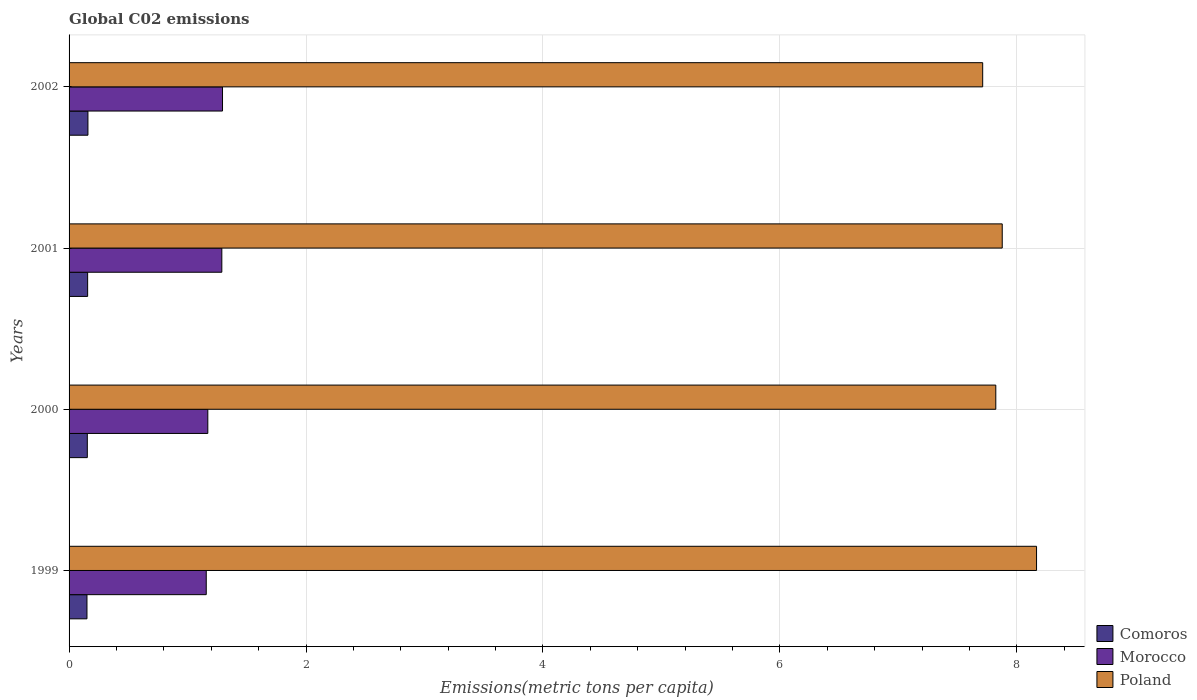Are the number of bars per tick equal to the number of legend labels?
Your response must be concise. Yes. Are the number of bars on each tick of the Y-axis equal?
Give a very brief answer. Yes. What is the label of the 4th group of bars from the top?
Your answer should be compact. 1999. In how many cases, is the number of bars for a given year not equal to the number of legend labels?
Provide a short and direct response. 0. What is the amount of CO2 emitted in in Comoros in 2001?
Offer a very short reply. 0.16. Across all years, what is the maximum amount of CO2 emitted in in Poland?
Offer a very short reply. 8.17. Across all years, what is the minimum amount of CO2 emitted in in Comoros?
Your response must be concise. 0.15. In which year was the amount of CO2 emitted in in Morocco maximum?
Give a very brief answer. 2002. What is the total amount of CO2 emitted in in Poland in the graph?
Offer a very short reply. 31.58. What is the difference between the amount of CO2 emitted in in Comoros in 1999 and that in 2000?
Your answer should be very brief. -0. What is the difference between the amount of CO2 emitted in in Comoros in 1999 and the amount of CO2 emitted in in Morocco in 2002?
Provide a short and direct response. -1.14. What is the average amount of CO2 emitted in in Poland per year?
Make the answer very short. 7.89. In the year 2002, what is the difference between the amount of CO2 emitted in in Morocco and amount of CO2 emitted in in Poland?
Your answer should be compact. -6.42. In how many years, is the amount of CO2 emitted in in Comoros greater than 6 metric tons per capita?
Provide a succinct answer. 0. What is the ratio of the amount of CO2 emitted in in Poland in 2000 to that in 2002?
Provide a short and direct response. 1.01. Is the difference between the amount of CO2 emitted in in Morocco in 2001 and 2002 greater than the difference between the amount of CO2 emitted in in Poland in 2001 and 2002?
Provide a succinct answer. No. What is the difference between the highest and the second highest amount of CO2 emitted in in Morocco?
Your response must be concise. 0.01. What is the difference between the highest and the lowest amount of CO2 emitted in in Comoros?
Offer a very short reply. 0.01. Is the sum of the amount of CO2 emitted in in Comoros in 1999 and 2002 greater than the maximum amount of CO2 emitted in in Poland across all years?
Offer a terse response. No. What does the 2nd bar from the top in 2001 represents?
Your answer should be compact. Morocco. Is it the case that in every year, the sum of the amount of CO2 emitted in in Morocco and amount of CO2 emitted in in Poland is greater than the amount of CO2 emitted in in Comoros?
Your answer should be compact. Yes. What is the difference between two consecutive major ticks on the X-axis?
Your response must be concise. 2. Does the graph contain any zero values?
Ensure brevity in your answer.  No. Where does the legend appear in the graph?
Provide a succinct answer. Bottom right. How are the legend labels stacked?
Give a very brief answer. Vertical. What is the title of the graph?
Ensure brevity in your answer.  Global C02 emissions. What is the label or title of the X-axis?
Make the answer very short. Emissions(metric tons per capita). What is the label or title of the Y-axis?
Your answer should be compact. Years. What is the Emissions(metric tons per capita) in Comoros in 1999?
Offer a terse response. 0.15. What is the Emissions(metric tons per capita) of Morocco in 1999?
Give a very brief answer. 1.16. What is the Emissions(metric tons per capita) of Poland in 1999?
Provide a succinct answer. 8.17. What is the Emissions(metric tons per capita) in Comoros in 2000?
Your response must be concise. 0.15. What is the Emissions(metric tons per capita) of Morocco in 2000?
Offer a very short reply. 1.17. What is the Emissions(metric tons per capita) in Poland in 2000?
Make the answer very short. 7.82. What is the Emissions(metric tons per capita) of Comoros in 2001?
Make the answer very short. 0.16. What is the Emissions(metric tons per capita) of Morocco in 2001?
Offer a very short reply. 1.29. What is the Emissions(metric tons per capita) in Poland in 2001?
Give a very brief answer. 7.88. What is the Emissions(metric tons per capita) in Comoros in 2002?
Keep it short and to the point. 0.16. What is the Emissions(metric tons per capita) in Morocco in 2002?
Offer a very short reply. 1.3. What is the Emissions(metric tons per capita) in Poland in 2002?
Give a very brief answer. 7.71. Across all years, what is the maximum Emissions(metric tons per capita) of Comoros?
Your response must be concise. 0.16. Across all years, what is the maximum Emissions(metric tons per capita) in Morocco?
Offer a terse response. 1.3. Across all years, what is the maximum Emissions(metric tons per capita) in Poland?
Make the answer very short. 8.17. Across all years, what is the minimum Emissions(metric tons per capita) in Comoros?
Ensure brevity in your answer.  0.15. Across all years, what is the minimum Emissions(metric tons per capita) of Morocco?
Offer a very short reply. 1.16. Across all years, what is the minimum Emissions(metric tons per capita) of Poland?
Offer a very short reply. 7.71. What is the total Emissions(metric tons per capita) in Comoros in the graph?
Your answer should be very brief. 0.62. What is the total Emissions(metric tons per capita) in Morocco in the graph?
Offer a very short reply. 4.91. What is the total Emissions(metric tons per capita) in Poland in the graph?
Keep it short and to the point. 31.58. What is the difference between the Emissions(metric tons per capita) of Comoros in 1999 and that in 2000?
Ensure brevity in your answer.  -0. What is the difference between the Emissions(metric tons per capita) in Morocco in 1999 and that in 2000?
Make the answer very short. -0.01. What is the difference between the Emissions(metric tons per capita) in Poland in 1999 and that in 2000?
Make the answer very short. 0.34. What is the difference between the Emissions(metric tons per capita) in Comoros in 1999 and that in 2001?
Your response must be concise. -0.01. What is the difference between the Emissions(metric tons per capita) of Morocco in 1999 and that in 2001?
Keep it short and to the point. -0.13. What is the difference between the Emissions(metric tons per capita) of Poland in 1999 and that in 2001?
Provide a short and direct response. 0.29. What is the difference between the Emissions(metric tons per capita) in Comoros in 1999 and that in 2002?
Give a very brief answer. -0.01. What is the difference between the Emissions(metric tons per capita) of Morocco in 1999 and that in 2002?
Ensure brevity in your answer.  -0.14. What is the difference between the Emissions(metric tons per capita) of Poland in 1999 and that in 2002?
Make the answer very short. 0.45. What is the difference between the Emissions(metric tons per capita) of Comoros in 2000 and that in 2001?
Keep it short and to the point. -0. What is the difference between the Emissions(metric tons per capita) in Morocco in 2000 and that in 2001?
Keep it short and to the point. -0.12. What is the difference between the Emissions(metric tons per capita) in Poland in 2000 and that in 2001?
Keep it short and to the point. -0.05. What is the difference between the Emissions(metric tons per capita) in Comoros in 2000 and that in 2002?
Make the answer very short. -0.01. What is the difference between the Emissions(metric tons per capita) of Morocco in 2000 and that in 2002?
Provide a succinct answer. -0.12. What is the difference between the Emissions(metric tons per capita) in Poland in 2000 and that in 2002?
Give a very brief answer. 0.11. What is the difference between the Emissions(metric tons per capita) in Comoros in 2001 and that in 2002?
Your answer should be compact. -0. What is the difference between the Emissions(metric tons per capita) of Morocco in 2001 and that in 2002?
Provide a succinct answer. -0.01. What is the difference between the Emissions(metric tons per capita) in Poland in 2001 and that in 2002?
Your answer should be compact. 0.17. What is the difference between the Emissions(metric tons per capita) of Comoros in 1999 and the Emissions(metric tons per capita) of Morocco in 2000?
Make the answer very short. -1.02. What is the difference between the Emissions(metric tons per capita) in Comoros in 1999 and the Emissions(metric tons per capita) in Poland in 2000?
Your response must be concise. -7.67. What is the difference between the Emissions(metric tons per capita) of Morocco in 1999 and the Emissions(metric tons per capita) of Poland in 2000?
Provide a succinct answer. -6.66. What is the difference between the Emissions(metric tons per capita) of Comoros in 1999 and the Emissions(metric tons per capita) of Morocco in 2001?
Offer a terse response. -1.14. What is the difference between the Emissions(metric tons per capita) of Comoros in 1999 and the Emissions(metric tons per capita) of Poland in 2001?
Provide a succinct answer. -7.73. What is the difference between the Emissions(metric tons per capita) in Morocco in 1999 and the Emissions(metric tons per capita) in Poland in 2001?
Keep it short and to the point. -6.72. What is the difference between the Emissions(metric tons per capita) in Comoros in 1999 and the Emissions(metric tons per capita) in Morocco in 2002?
Make the answer very short. -1.14. What is the difference between the Emissions(metric tons per capita) of Comoros in 1999 and the Emissions(metric tons per capita) of Poland in 2002?
Make the answer very short. -7.56. What is the difference between the Emissions(metric tons per capita) of Morocco in 1999 and the Emissions(metric tons per capita) of Poland in 2002?
Your answer should be very brief. -6.55. What is the difference between the Emissions(metric tons per capita) of Comoros in 2000 and the Emissions(metric tons per capita) of Morocco in 2001?
Your response must be concise. -1.14. What is the difference between the Emissions(metric tons per capita) in Comoros in 2000 and the Emissions(metric tons per capita) in Poland in 2001?
Your answer should be compact. -7.72. What is the difference between the Emissions(metric tons per capita) in Morocco in 2000 and the Emissions(metric tons per capita) in Poland in 2001?
Ensure brevity in your answer.  -6.71. What is the difference between the Emissions(metric tons per capita) in Comoros in 2000 and the Emissions(metric tons per capita) in Morocco in 2002?
Ensure brevity in your answer.  -1.14. What is the difference between the Emissions(metric tons per capita) in Comoros in 2000 and the Emissions(metric tons per capita) in Poland in 2002?
Make the answer very short. -7.56. What is the difference between the Emissions(metric tons per capita) of Morocco in 2000 and the Emissions(metric tons per capita) of Poland in 2002?
Your answer should be very brief. -6.54. What is the difference between the Emissions(metric tons per capita) in Comoros in 2001 and the Emissions(metric tons per capita) in Morocco in 2002?
Your answer should be compact. -1.14. What is the difference between the Emissions(metric tons per capita) of Comoros in 2001 and the Emissions(metric tons per capita) of Poland in 2002?
Your response must be concise. -7.55. What is the difference between the Emissions(metric tons per capita) of Morocco in 2001 and the Emissions(metric tons per capita) of Poland in 2002?
Your response must be concise. -6.42. What is the average Emissions(metric tons per capita) of Comoros per year?
Give a very brief answer. 0.16. What is the average Emissions(metric tons per capita) in Morocco per year?
Provide a short and direct response. 1.23. What is the average Emissions(metric tons per capita) in Poland per year?
Your answer should be very brief. 7.89. In the year 1999, what is the difference between the Emissions(metric tons per capita) of Comoros and Emissions(metric tons per capita) of Morocco?
Offer a very short reply. -1.01. In the year 1999, what is the difference between the Emissions(metric tons per capita) of Comoros and Emissions(metric tons per capita) of Poland?
Offer a terse response. -8.02. In the year 1999, what is the difference between the Emissions(metric tons per capita) in Morocco and Emissions(metric tons per capita) in Poland?
Keep it short and to the point. -7.01. In the year 2000, what is the difference between the Emissions(metric tons per capita) of Comoros and Emissions(metric tons per capita) of Morocco?
Make the answer very short. -1.02. In the year 2000, what is the difference between the Emissions(metric tons per capita) of Comoros and Emissions(metric tons per capita) of Poland?
Offer a very short reply. -7.67. In the year 2000, what is the difference between the Emissions(metric tons per capita) in Morocco and Emissions(metric tons per capita) in Poland?
Your answer should be compact. -6.65. In the year 2001, what is the difference between the Emissions(metric tons per capita) of Comoros and Emissions(metric tons per capita) of Morocco?
Ensure brevity in your answer.  -1.13. In the year 2001, what is the difference between the Emissions(metric tons per capita) in Comoros and Emissions(metric tons per capita) in Poland?
Make the answer very short. -7.72. In the year 2001, what is the difference between the Emissions(metric tons per capita) in Morocco and Emissions(metric tons per capita) in Poland?
Provide a succinct answer. -6.59. In the year 2002, what is the difference between the Emissions(metric tons per capita) in Comoros and Emissions(metric tons per capita) in Morocco?
Offer a terse response. -1.14. In the year 2002, what is the difference between the Emissions(metric tons per capita) of Comoros and Emissions(metric tons per capita) of Poland?
Provide a succinct answer. -7.55. In the year 2002, what is the difference between the Emissions(metric tons per capita) in Morocco and Emissions(metric tons per capita) in Poland?
Keep it short and to the point. -6.42. What is the ratio of the Emissions(metric tons per capita) of Comoros in 1999 to that in 2000?
Make the answer very short. 0.98. What is the ratio of the Emissions(metric tons per capita) of Morocco in 1999 to that in 2000?
Your answer should be compact. 0.99. What is the ratio of the Emissions(metric tons per capita) of Poland in 1999 to that in 2000?
Offer a very short reply. 1.04. What is the ratio of the Emissions(metric tons per capita) in Comoros in 1999 to that in 2001?
Your answer should be very brief. 0.96. What is the ratio of the Emissions(metric tons per capita) of Morocco in 1999 to that in 2001?
Keep it short and to the point. 0.9. What is the ratio of the Emissions(metric tons per capita) of Poland in 1999 to that in 2001?
Give a very brief answer. 1.04. What is the ratio of the Emissions(metric tons per capita) in Comoros in 1999 to that in 2002?
Provide a short and direct response. 0.95. What is the ratio of the Emissions(metric tons per capita) in Morocco in 1999 to that in 2002?
Give a very brief answer. 0.89. What is the ratio of the Emissions(metric tons per capita) in Poland in 1999 to that in 2002?
Give a very brief answer. 1.06. What is the ratio of the Emissions(metric tons per capita) of Comoros in 2000 to that in 2001?
Keep it short and to the point. 0.98. What is the ratio of the Emissions(metric tons per capita) of Morocco in 2000 to that in 2001?
Keep it short and to the point. 0.91. What is the ratio of the Emissions(metric tons per capita) of Comoros in 2000 to that in 2002?
Ensure brevity in your answer.  0.97. What is the ratio of the Emissions(metric tons per capita) in Morocco in 2000 to that in 2002?
Provide a short and direct response. 0.9. What is the ratio of the Emissions(metric tons per capita) of Poland in 2000 to that in 2002?
Provide a succinct answer. 1.01. What is the ratio of the Emissions(metric tons per capita) in Comoros in 2001 to that in 2002?
Offer a terse response. 0.98. What is the ratio of the Emissions(metric tons per capita) of Morocco in 2001 to that in 2002?
Offer a terse response. 1. What is the ratio of the Emissions(metric tons per capita) of Poland in 2001 to that in 2002?
Provide a short and direct response. 1.02. What is the difference between the highest and the second highest Emissions(metric tons per capita) in Comoros?
Your answer should be compact. 0. What is the difference between the highest and the second highest Emissions(metric tons per capita) in Morocco?
Give a very brief answer. 0.01. What is the difference between the highest and the second highest Emissions(metric tons per capita) in Poland?
Offer a terse response. 0.29. What is the difference between the highest and the lowest Emissions(metric tons per capita) of Comoros?
Your answer should be compact. 0.01. What is the difference between the highest and the lowest Emissions(metric tons per capita) in Morocco?
Your answer should be very brief. 0.14. What is the difference between the highest and the lowest Emissions(metric tons per capita) in Poland?
Your response must be concise. 0.45. 